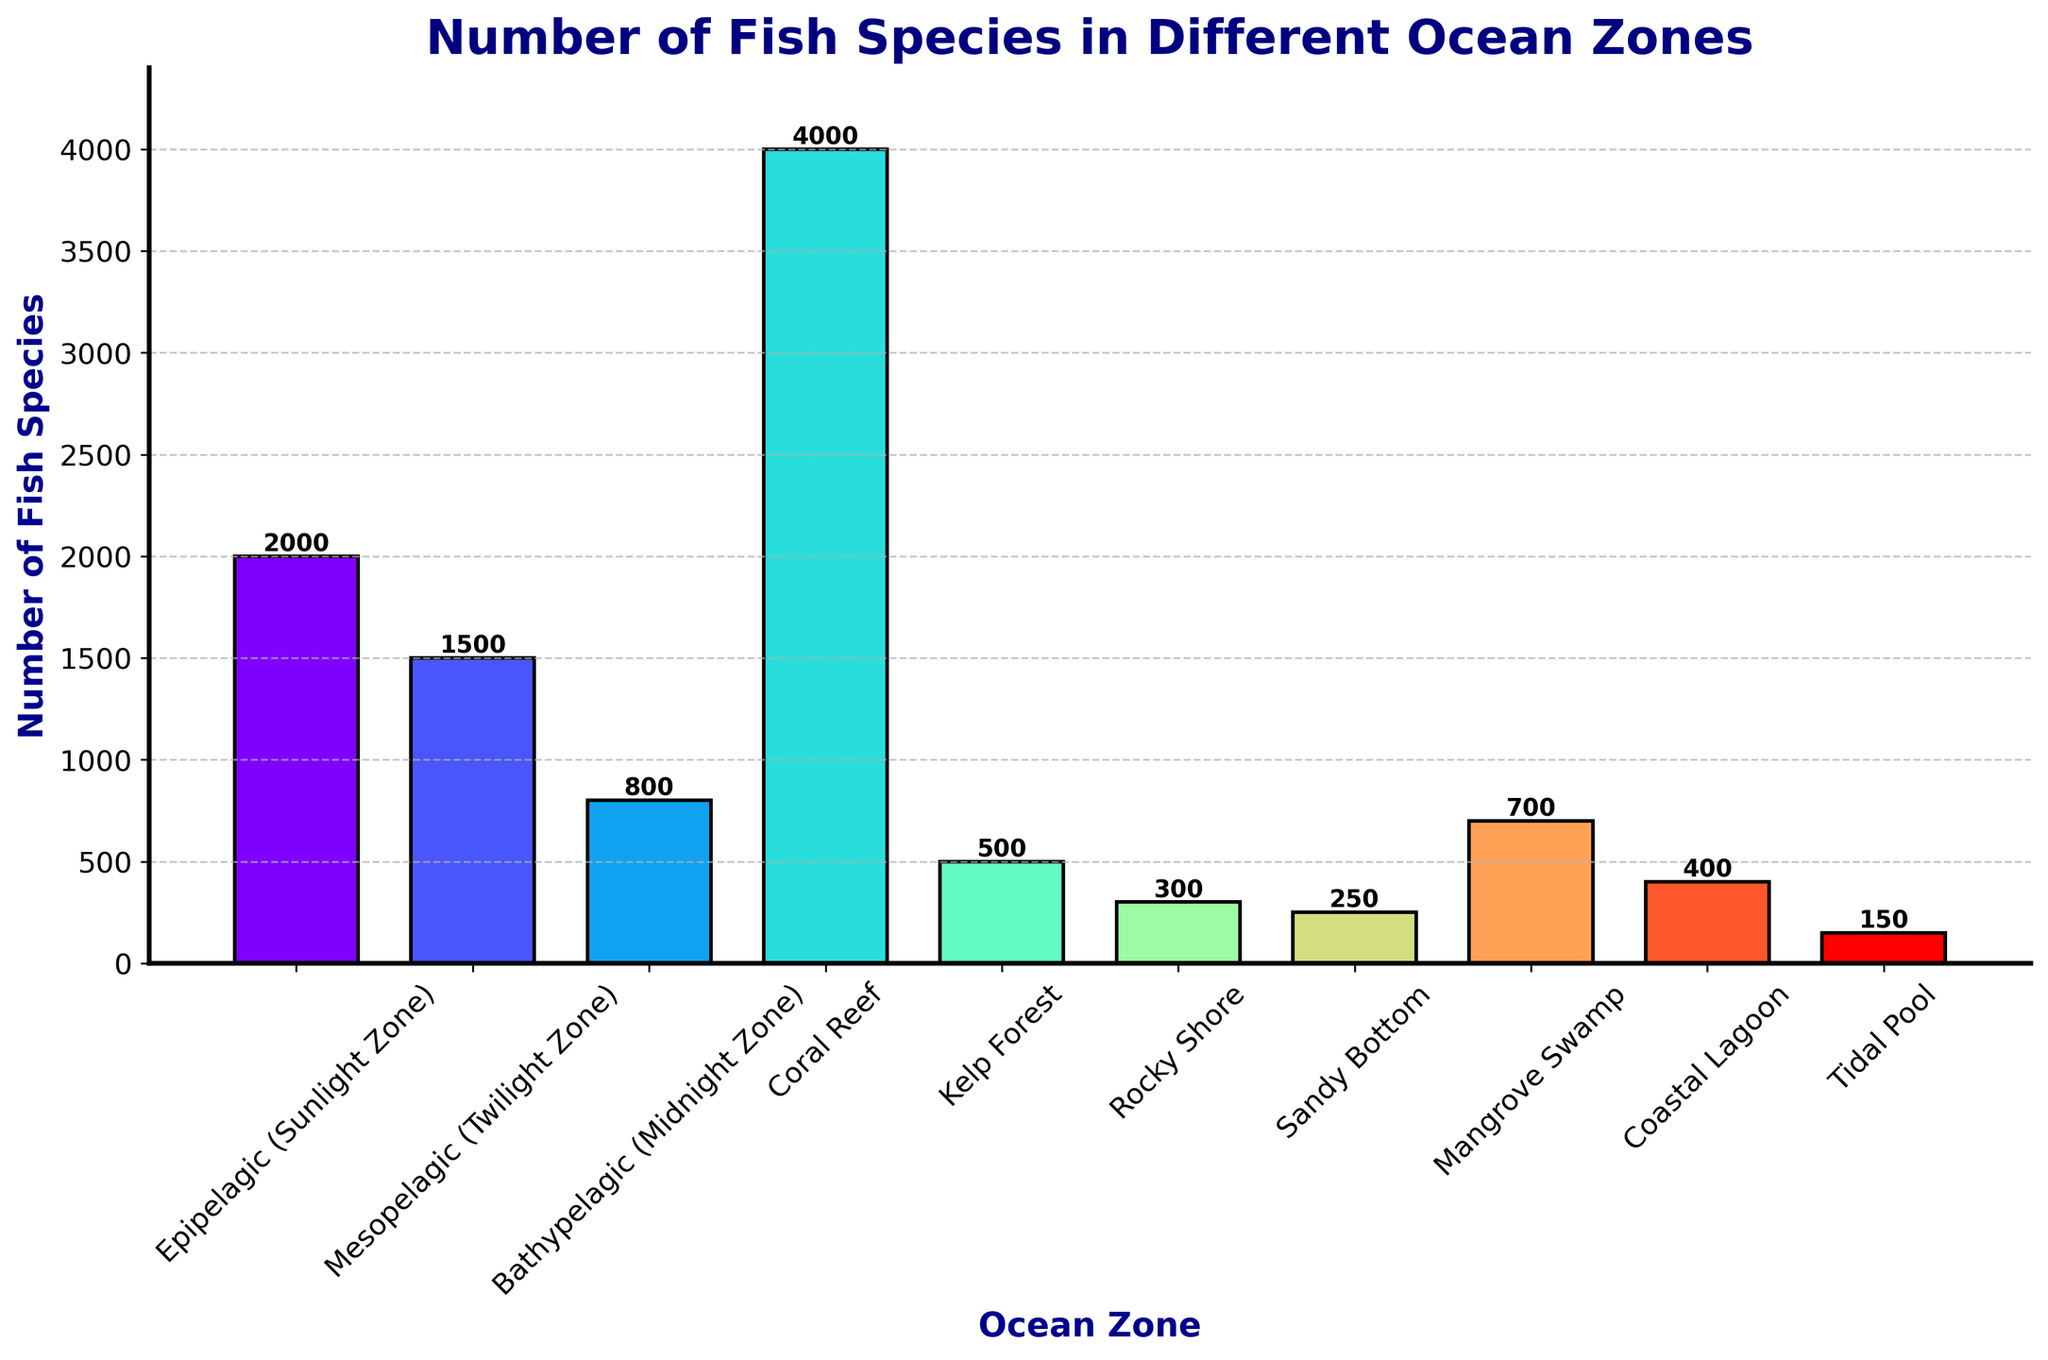What ocean zone has the most fish species? Look at the height of the bars. The Coral Reef zone bar is the tallest, indicating it has the most species.
Answer: Coral Reef Which ocean zones have fewer than 500 fish species? Identify bars with heights less than the tick mark at 500. These zones are Rocky Shore, Sandy Bottom, Coastal Lagoon, and Tidal Pool.
Answer: Rocky Shore, Sandy Bottom, Coastal Lagoon, Tidal Pool How many more fish species are in the Epipelagic zone than in the Bathypelagic zone? Find the difference in bar heights for the Epipelagic (2000) and Bathypelagic (800) zones. 2000 - 800 = 1200.
Answer: 1200 What is the combined number of fish species in Rocky Shore and Tidal Pool? Add the numbers for these zones: 300 (Rocky Shore) + 150 (Tidal Pool) = 450.
Answer: 450 Which zone has fewer fish species, the Mesopelagic zone or the Kelp Forest? Compare their bar heights. Mesopelagic (1500) is greater than Kelp Forest (500), so Kelp Forest has fewer.
Answer: Kelp Forest How many fish species are in the Coastal Lagoon compared to the Mangrove Swamp? Compare the numbers directly from the bar heights: Coastal Lagoon (400), Mangrove Swamp (700). Coastal Lagoon has fewer species.
Answer: Coastal Lagoon Which zones have between 200 and 800 fish species? Identify the zones with bar heights between these values: Kelp Forest (500), Rocky Shore (300), Sandy Bottom (250), Coastal Lagoon (400), Mangrove Swamp (700).
Answer: Kelp Forest, Rocky Shore, Sandy Bottom, Coastal Lagoon, Mangrove Swamp What is the average number of fish species across all zones? Sum all species numbers and divide by the number of zones: (2000 + 1500 + 800 + 4000 + 500 + 300 + 250 + 700 + 400 + 150) / 10 = 10600 / 10 = 1060.
Answer: 1060 How many more fish species are in the Coral Reef than in the Coastal Lagoon and Tidal Pool combined? Find the difference between Coral Reef (4000) and the sum of Coastal Lagoon (400) + Tidal Pool (150). 4000 - (400 + 150) = 4000 - 550 = 3450.
Answer: 3450 